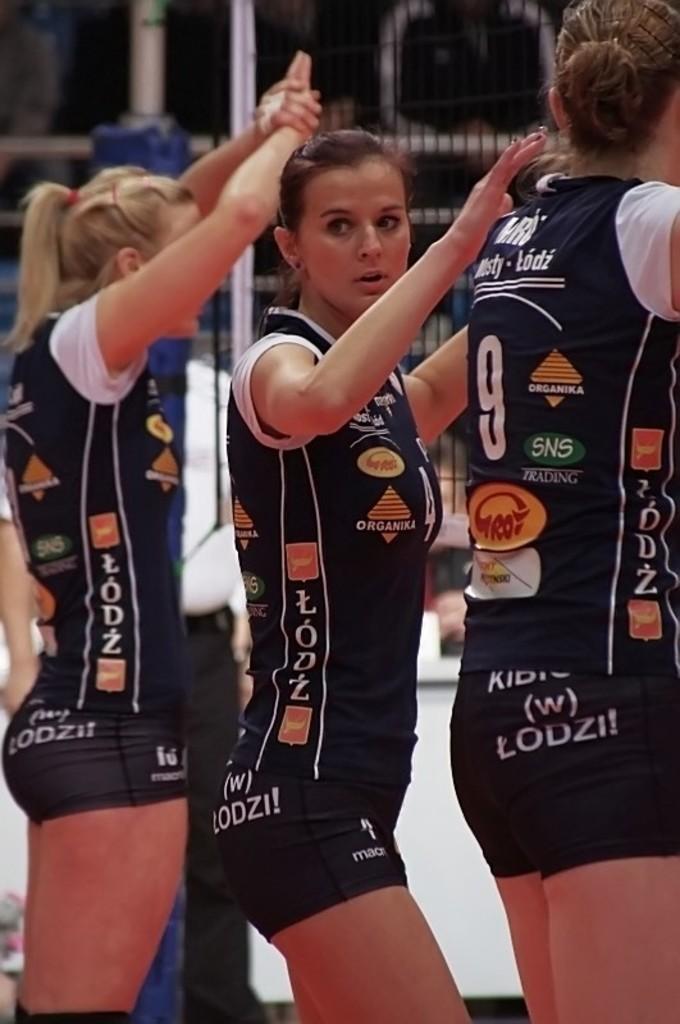What number is the player on the right?
Make the answer very short. 9. What is the number of the player to the left?
Offer a very short reply. Unanswerable. 